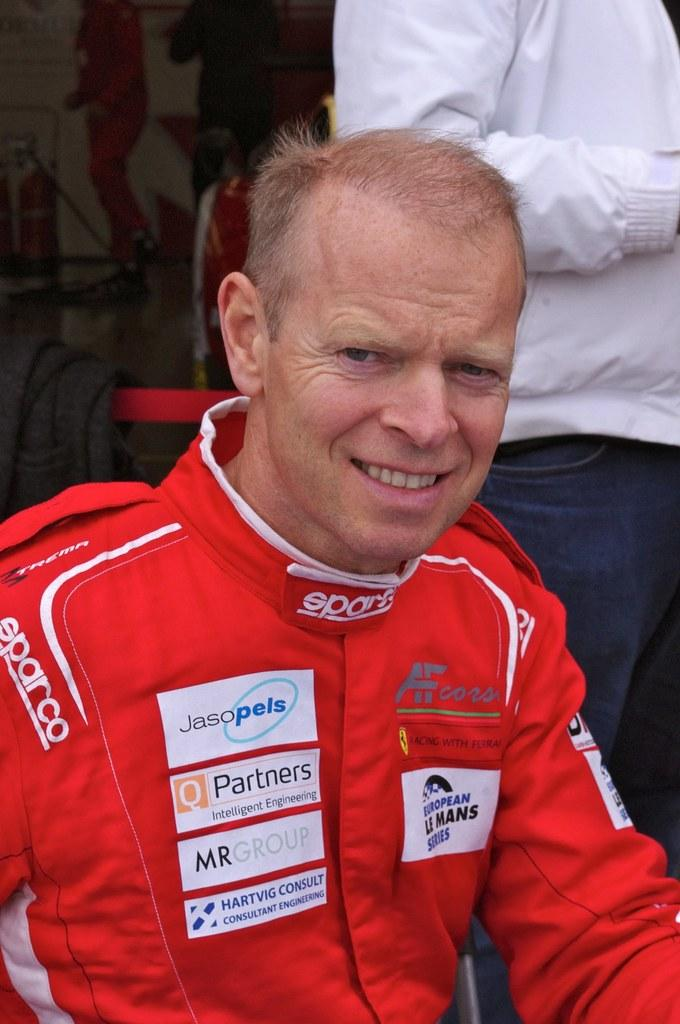<image>
Create a compact narrative representing the image presented. A man is in a racing suit with a Jasopels logo on it. 